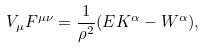Convert formula to latex. <formula><loc_0><loc_0><loc_500><loc_500>V _ { \mu } F ^ { \mu \nu } = \frac { 1 } { \rho ^ { 2 } } ( E K ^ { \alpha } - W ^ { \alpha } ) ,</formula> 